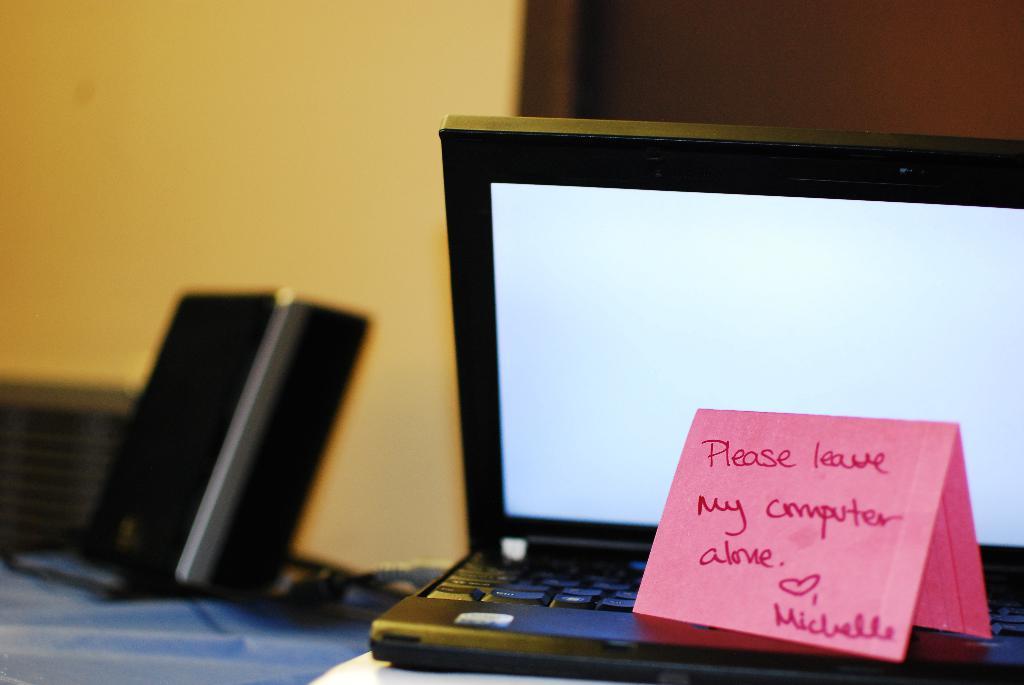What does the sticky note say to do with the computer?
Offer a terse response. Leave it alone. 